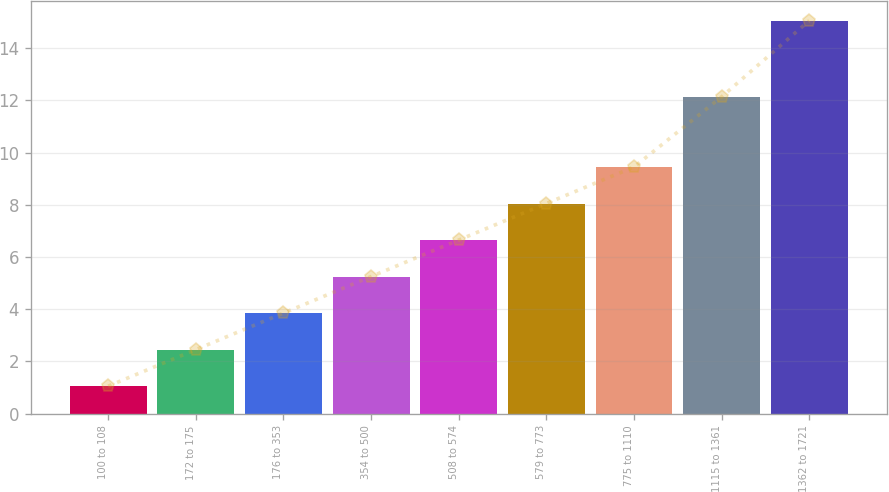Convert chart. <chart><loc_0><loc_0><loc_500><loc_500><bar_chart><fcel>100 to 108<fcel>172 to 175<fcel>176 to 353<fcel>354 to 500<fcel>508 to 574<fcel>579 to 773<fcel>775 to 1110<fcel>1115 to 1361<fcel>1362 to 1721<nl><fcel>1.05<fcel>2.45<fcel>3.85<fcel>5.25<fcel>6.65<fcel>8.05<fcel>9.45<fcel>12.14<fcel>15.06<nl></chart> 